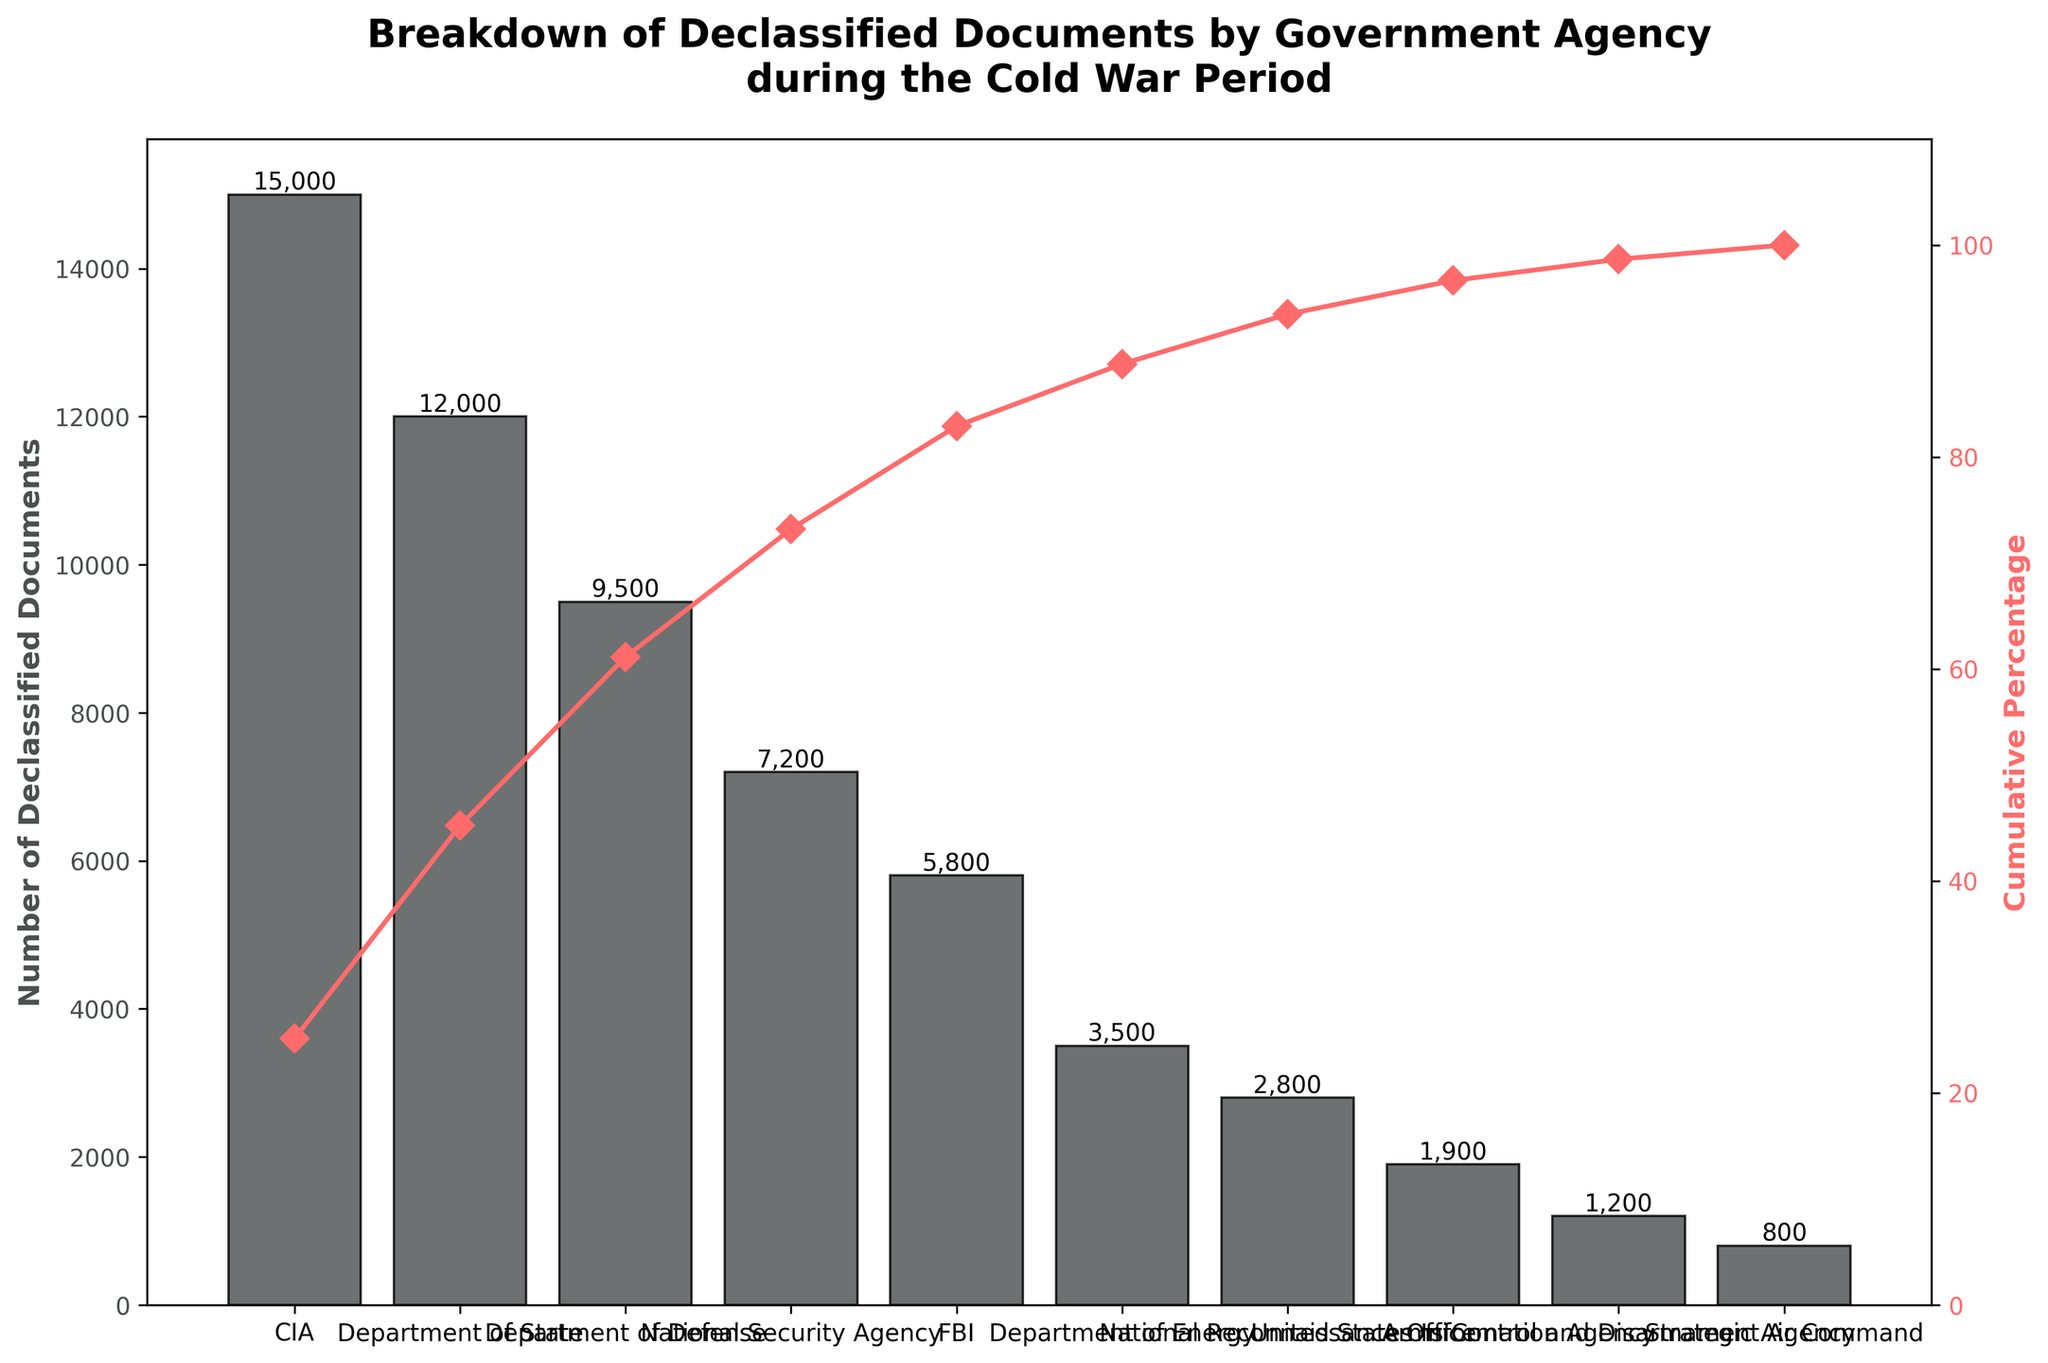What is the title of the figure? The title of the figure is the text at the top of the chart that describes the subject of the data.
Answer: Breakdown of Declassified Documents by Government Agency during the Cold War Period How many government agencies are represented in the chart? Count the number of different agencies listed on the x-axis.
Answer: 10 Which agency has the highest number of declassified documents? Identify the agency associated with the tallest bar on the primary y-axis.
Answer: CIA What is the cumulative percentage of the top three agencies with the most declassified documents? Add the cumulative percentages of the top three agencies as indicated by the secondary y-axis.
Answer: About 58% What is the combined number of declassified documents from the FBI and the Department of Energy? Add the number of declassified documents for the FBI (5800) and the Department of Energy (3500).
Answer: 9300 Which agency has the lowest number of declassified documents? Identify the agency associated with the shortest bar on the primary y-axis.
Answer: Strategic Air Command How does the number of declassified documents for the Department of Defense compare to the Department of State? Compare the height of the bars and the values on top of them for the Department of Defense (9500) and the Department of State (12000).
Answer: The Department of State has 2500 more declassified documents than the Department of Defense What percentage of the total declassified documents does the National Security Agency account for? Calculate the percentage by dividing the number of documents for the National Security Agency (7200) by the total number of documents and then multiply by 100.
Answer: About 12% Which agencies fall into the category of contributing less than 5% to the cumulative percentage? Identify the agencies on the x-axis where the corresponding cumulative percentage on the secondary y-axis is below 5% and less than each preceding percentage seen already (closer to upward view).
Answer: Strategic Air Command, Arms Control and Disarmament Agency, United States Information Agency How does the number of declassified documents vary visually between the National Reconnaissance Office and the Department of Energy? Compare the height of the bars representing the National Reconnaissance Office (2800) and the Department of Energy (3500) and note the difference.
Answer: The Department of Energy has 700 more declassified documents than the National Reconnaissance Office 